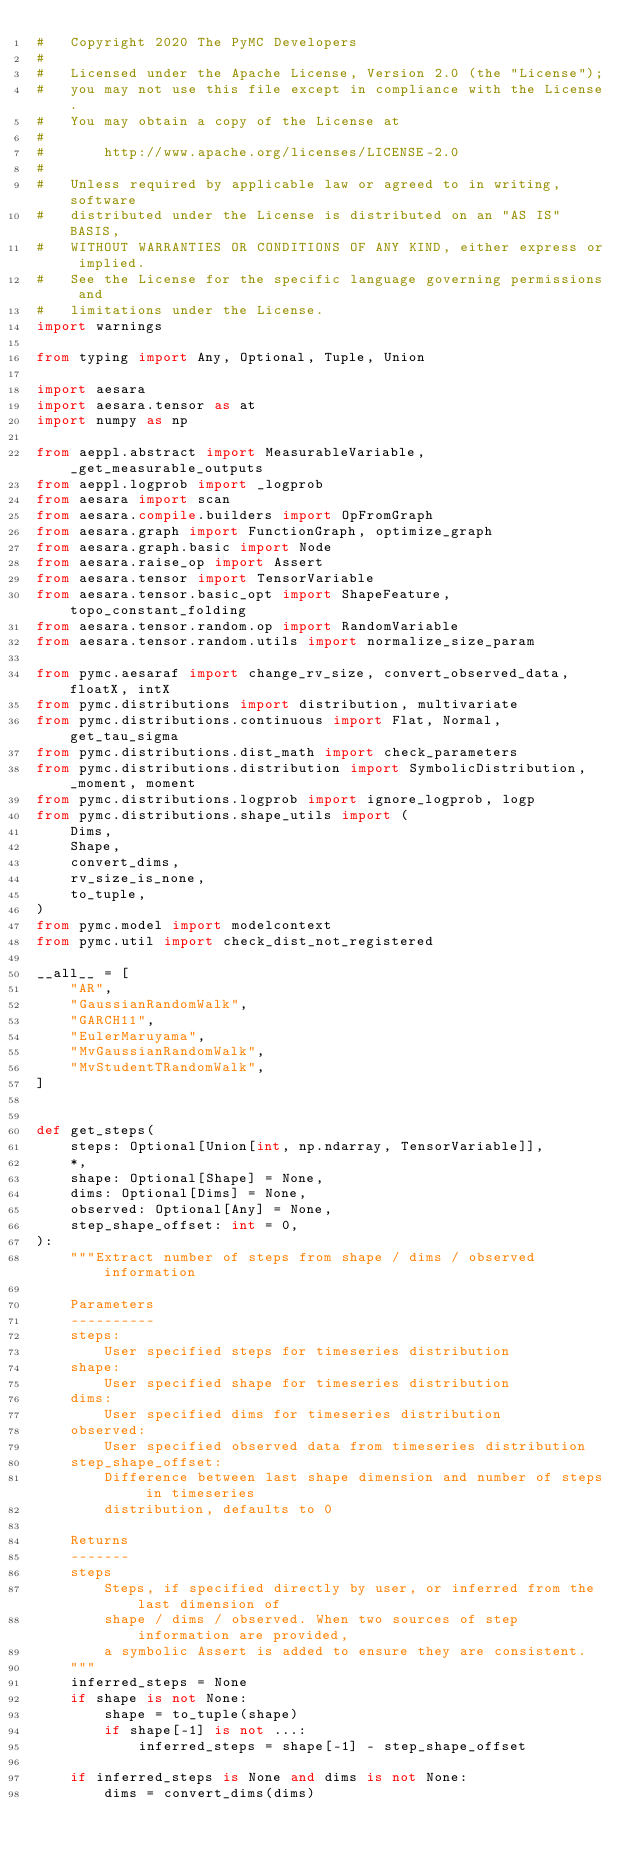<code> <loc_0><loc_0><loc_500><loc_500><_Python_>#   Copyright 2020 The PyMC Developers
#
#   Licensed under the Apache License, Version 2.0 (the "License");
#   you may not use this file except in compliance with the License.
#   You may obtain a copy of the License at
#
#       http://www.apache.org/licenses/LICENSE-2.0
#
#   Unless required by applicable law or agreed to in writing, software
#   distributed under the License is distributed on an "AS IS" BASIS,
#   WITHOUT WARRANTIES OR CONDITIONS OF ANY KIND, either express or implied.
#   See the License for the specific language governing permissions and
#   limitations under the License.
import warnings

from typing import Any, Optional, Tuple, Union

import aesara
import aesara.tensor as at
import numpy as np

from aeppl.abstract import MeasurableVariable, _get_measurable_outputs
from aeppl.logprob import _logprob
from aesara import scan
from aesara.compile.builders import OpFromGraph
from aesara.graph import FunctionGraph, optimize_graph
from aesara.graph.basic import Node
from aesara.raise_op import Assert
from aesara.tensor import TensorVariable
from aesara.tensor.basic_opt import ShapeFeature, topo_constant_folding
from aesara.tensor.random.op import RandomVariable
from aesara.tensor.random.utils import normalize_size_param

from pymc.aesaraf import change_rv_size, convert_observed_data, floatX, intX
from pymc.distributions import distribution, multivariate
from pymc.distributions.continuous import Flat, Normal, get_tau_sigma
from pymc.distributions.dist_math import check_parameters
from pymc.distributions.distribution import SymbolicDistribution, _moment, moment
from pymc.distributions.logprob import ignore_logprob, logp
from pymc.distributions.shape_utils import (
    Dims,
    Shape,
    convert_dims,
    rv_size_is_none,
    to_tuple,
)
from pymc.model import modelcontext
from pymc.util import check_dist_not_registered

__all__ = [
    "AR",
    "GaussianRandomWalk",
    "GARCH11",
    "EulerMaruyama",
    "MvGaussianRandomWalk",
    "MvStudentTRandomWalk",
]


def get_steps(
    steps: Optional[Union[int, np.ndarray, TensorVariable]],
    *,
    shape: Optional[Shape] = None,
    dims: Optional[Dims] = None,
    observed: Optional[Any] = None,
    step_shape_offset: int = 0,
):
    """Extract number of steps from shape / dims / observed information

    Parameters
    ----------
    steps:
        User specified steps for timeseries distribution
    shape:
        User specified shape for timeseries distribution
    dims:
        User specified dims for timeseries distribution
    observed:
        User specified observed data from timeseries distribution
    step_shape_offset:
        Difference between last shape dimension and number of steps in timeseries
        distribution, defaults to 0

    Returns
    -------
    steps
        Steps, if specified directly by user, or inferred from the last dimension of
        shape / dims / observed. When two sources of step information are provided,
        a symbolic Assert is added to ensure they are consistent.
    """
    inferred_steps = None
    if shape is not None:
        shape = to_tuple(shape)
        if shape[-1] is not ...:
            inferred_steps = shape[-1] - step_shape_offset

    if inferred_steps is None and dims is not None:
        dims = convert_dims(dims)</code> 